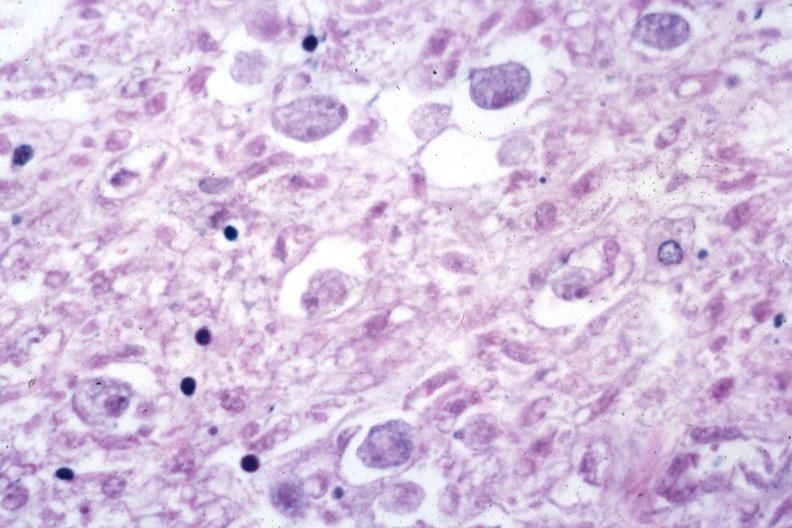what does this image show?
Answer the question using a single word or phrase. Trophozoites in tissue 